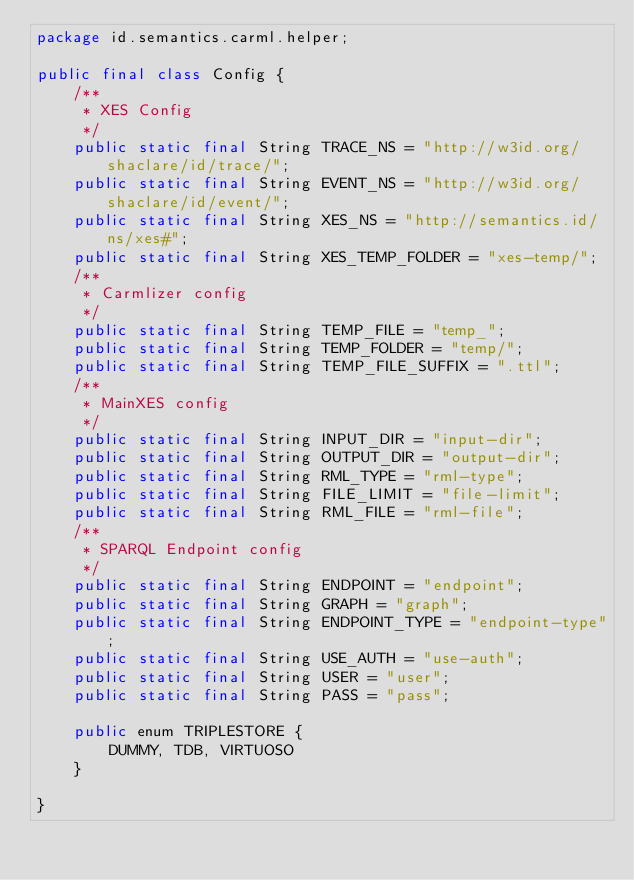Convert code to text. <code><loc_0><loc_0><loc_500><loc_500><_Java_>package id.semantics.carml.helper;

public final class Config {
    /**
     * XES Config
     */
    public static final String TRACE_NS = "http://w3id.org/shaclare/id/trace/";
    public static final String EVENT_NS = "http://w3id.org/shaclare/id/event/";
    public static final String XES_NS = "http://semantics.id/ns/xes#";
    public static final String XES_TEMP_FOLDER = "xes-temp/";
    /**
     * Carmlizer config
     */
    public static final String TEMP_FILE = "temp_";
    public static final String TEMP_FOLDER = "temp/";
    public static final String TEMP_FILE_SUFFIX = ".ttl";
    /**
     * MainXES config
     */
    public static final String INPUT_DIR = "input-dir";
    public static final String OUTPUT_DIR = "output-dir";
    public static final String RML_TYPE = "rml-type";
    public static final String FILE_LIMIT = "file-limit";
    public static final String RML_FILE = "rml-file";
    /**
     * SPARQL Endpoint config
     */
    public static final String ENDPOINT = "endpoint";
    public static final String GRAPH = "graph";
    public static final String ENDPOINT_TYPE = "endpoint-type";
    public static final String USE_AUTH = "use-auth";
    public static final String USER = "user";
    public static final String PASS = "pass";

    public enum TRIPLESTORE {
        DUMMY, TDB, VIRTUOSO
    }

}
</code> 